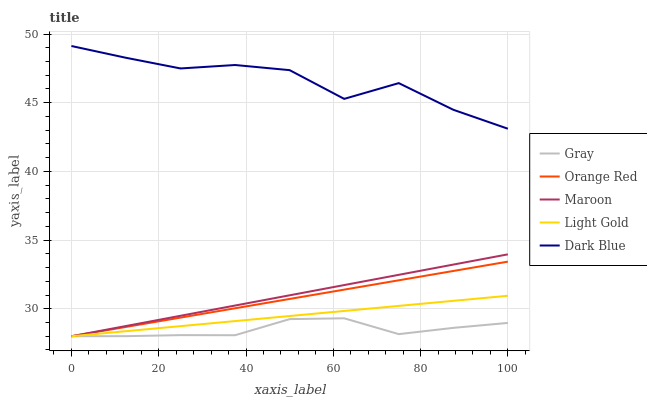Does Gray have the minimum area under the curve?
Answer yes or no. Yes. Does Dark Blue have the maximum area under the curve?
Answer yes or no. Yes. Does Light Gold have the minimum area under the curve?
Answer yes or no. No. Does Light Gold have the maximum area under the curve?
Answer yes or no. No. Is Light Gold the smoothest?
Answer yes or no. Yes. Is Dark Blue the roughest?
Answer yes or no. Yes. Is Orange Red the smoothest?
Answer yes or no. No. Is Orange Red the roughest?
Answer yes or no. No. Does Gray have the lowest value?
Answer yes or no. Yes. Does Dark Blue have the lowest value?
Answer yes or no. No. Does Dark Blue have the highest value?
Answer yes or no. Yes. Does Light Gold have the highest value?
Answer yes or no. No. Is Light Gold less than Dark Blue?
Answer yes or no. Yes. Is Dark Blue greater than Gray?
Answer yes or no. Yes. Does Orange Red intersect Light Gold?
Answer yes or no. Yes. Is Orange Red less than Light Gold?
Answer yes or no. No. Is Orange Red greater than Light Gold?
Answer yes or no. No. Does Light Gold intersect Dark Blue?
Answer yes or no. No. 